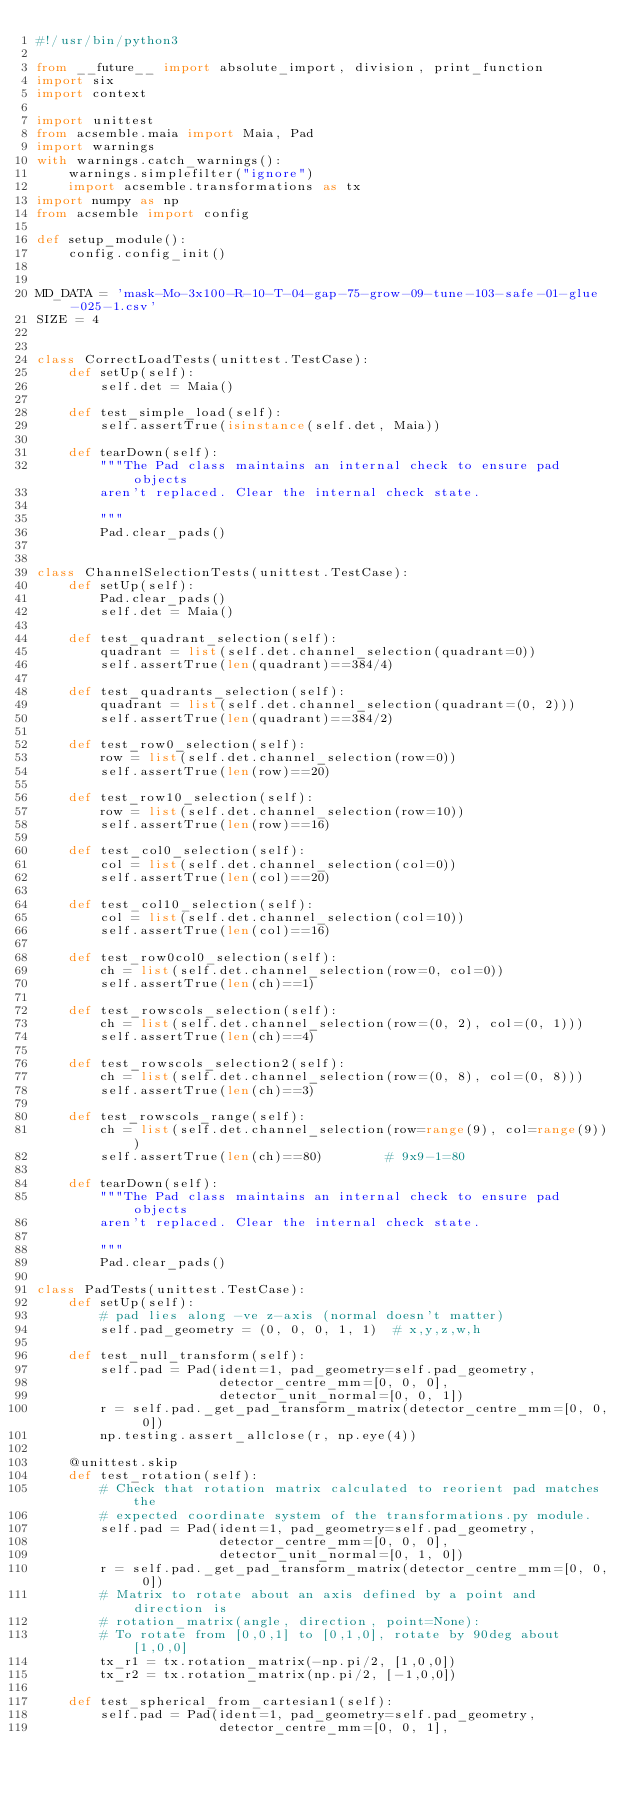<code> <loc_0><loc_0><loc_500><loc_500><_Python_>#!/usr/bin/python3

from __future__ import absolute_import, division, print_function
import six
import context

import unittest
from acsemble.maia import Maia, Pad
import warnings
with warnings.catch_warnings():
    warnings.simplefilter("ignore")
    import acsemble.transformations as tx
import numpy as np
from acsemble import config

def setup_module():
    config.config_init()


MD_DATA = 'mask-Mo-3x100-R-10-T-04-gap-75-grow-09-tune-103-safe-01-glue-025-1.csv'
SIZE = 4


class CorrectLoadTests(unittest.TestCase):
    def setUp(self):
        self.det = Maia()

    def test_simple_load(self):
        self.assertTrue(isinstance(self.det, Maia))

    def tearDown(self):
        """The Pad class maintains an internal check to ensure pad objects
        aren't replaced. Clear the internal check state.

        """
        Pad.clear_pads()


class ChannelSelectionTests(unittest.TestCase):
    def setUp(self):
        Pad.clear_pads()
        self.det = Maia()

    def test_quadrant_selection(self):
        quadrant = list(self.det.channel_selection(quadrant=0))
        self.assertTrue(len(quadrant)==384/4)

    def test_quadrants_selection(self):
        quadrant = list(self.det.channel_selection(quadrant=(0, 2)))
        self.assertTrue(len(quadrant)==384/2)

    def test_row0_selection(self):
        row = list(self.det.channel_selection(row=0))
        self.assertTrue(len(row)==20)

    def test_row10_selection(self):
        row = list(self.det.channel_selection(row=10))
        self.assertTrue(len(row)==16)

    def test_col0_selection(self):
        col = list(self.det.channel_selection(col=0))
        self.assertTrue(len(col)==20)

    def test_col10_selection(self):
        col = list(self.det.channel_selection(col=10))
        self.assertTrue(len(col)==16)

    def test_row0col0_selection(self):
        ch = list(self.det.channel_selection(row=0, col=0))
        self.assertTrue(len(ch)==1)

    def test_rowscols_selection(self):
        ch = list(self.det.channel_selection(row=(0, 2), col=(0, 1)))
        self.assertTrue(len(ch)==4)

    def test_rowscols_selection2(self):
        ch = list(self.det.channel_selection(row=(0, 8), col=(0, 8)))
        self.assertTrue(len(ch)==3)

    def test_rowscols_range(self):
        ch = list(self.det.channel_selection(row=range(9), col=range(9)))
        self.assertTrue(len(ch)==80)        # 9x9-1=80

    def tearDown(self):
        """The Pad class maintains an internal check to ensure pad objects
        aren't replaced. Clear the internal check state.

        """
        Pad.clear_pads()

class PadTests(unittest.TestCase):
    def setUp(self):
        # pad lies along -ve z-axis (normal doesn't matter)
        self.pad_geometry = (0, 0, 0, 1, 1)  # x,y,z,w,h

    def test_null_transform(self):
        self.pad = Pad(ident=1, pad_geometry=self.pad_geometry,
                       detector_centre_mm=[0, 0, 0],
                       detector_unit_normal=[0, 0, 1])
        r = self.pad._get_pad_transform_matrix(detector_centre_mm=[0, 0, 0])
        np.testing.assert_allclose(r, np.eye(4))

    @unittest.skip
    def test_rotation(self):
        # Check that rotation matrix calculated to reorient pad matches the
        # expected coordinate system of the transformations.py module.
        self.pad = Pad(ident=1, pad_geometry=self.pad_geometry,
                       detector_centre_mm=[0, 0, 0],
                       detector_unit_normal=[0, 1, 0])
        r = self.pad._get_pad_transform_matrix(detector_centre_mm=[0, 0, 0])
        # Matrix to rotate about an axis defined by a point and direction is
        # rotation_matrix(angle, direction, point=None):
        # To rotate from [0,0,1] to [0,1,0], rotate by 90deg about [1,0,0]
        tx_r1 = tx.rotation_matrix(-np.pi/2, [1,0,0])
        tx_r2 = tx.rotation_matrix(np.pi/2, [-1,0,0])

    def test_spherical_from_cartesian1(self):
        self.pad = Pad(ident=1, pad_geometry=self.pad_geometry,
                       detector_centre_mm=[0, 0, 1],</code> 